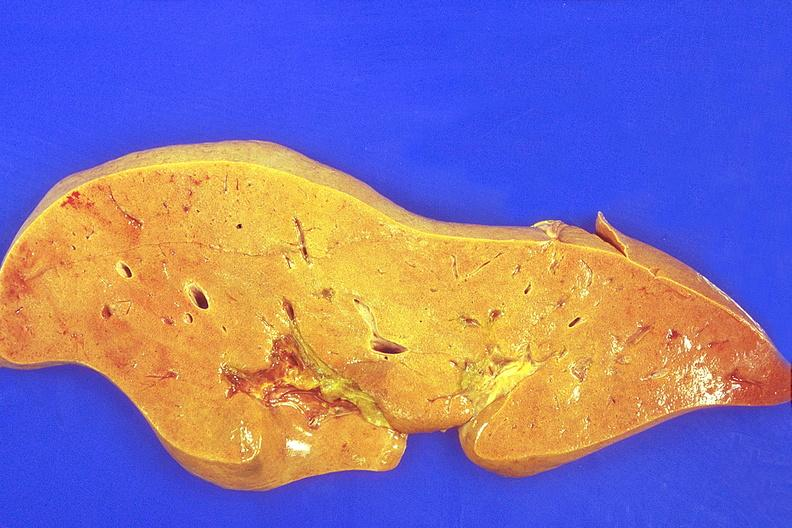does appendix show liver, fatty change?
Answer the question using a single word or phrase. No 